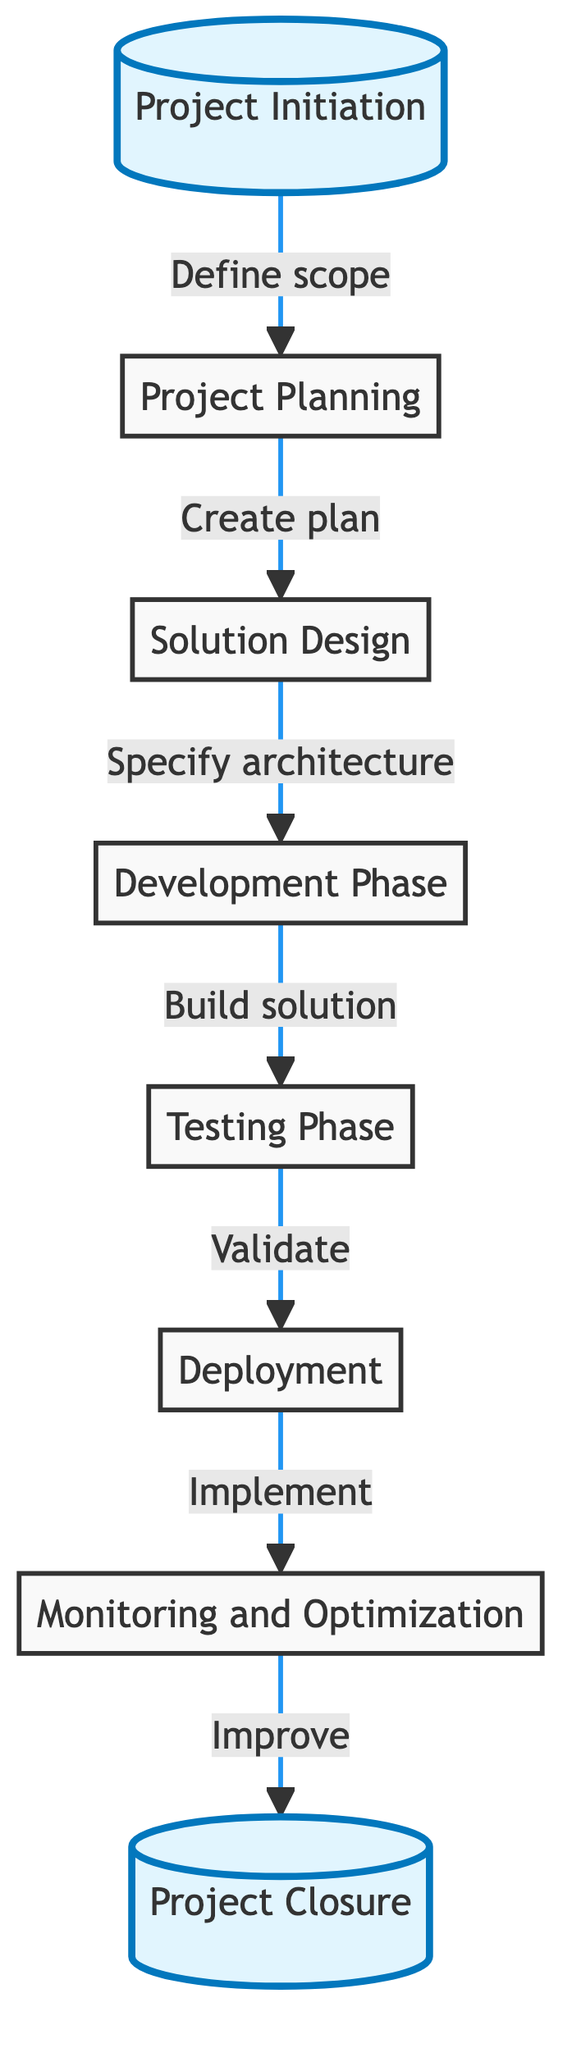What is the first phase of the automation project lifecycle? The diagram indicates that the first phase is "Project Initiation," which is positioned at the starting point of the flowchart.
Answer: Project Initiation How many total phases are there in the automation project lifecycle? By counting the nodes listed in the diagram, we find that there are eight distinct phases: Initiation, Planning, Design, Development, Testing, Deployment, Monitoring, and Closure.
Answer: Eight What phase comes directly after the Testing Phase? Following the flow of the diagram, the phase that directly follows "Testing Phase" is "Deployment." This indicates the sequence of operations in the project lifecycle.
Answer: Deployment Which phase involves creating a detailed project plan? According to the flowchart, the phase responsible for this task is "Project Planning," as it explicitly mentions developing a detailed project plan.
Answer: Project Planning What action follows the Deployment phase? The diagram shows that after "Deployment," the next action is "Monitoring and Optimization." This indicates the continuous process that occurs post-deployment.
Answer: Monitoring and Optimization What is the final phase in the automation project lifecycle? In the flowchart, the last phase is marked as "Project Closure," signifying the conclusion of the project lifecycle.
Answer: Project Closure Which two phases are highlighted in the diagram? The highlighted phases in the diagram are "Project Initiation" and "Project Closure," indicating their importance in the lifecycle process.
Answer: Project Initiation and Project Closure What is the connection between the Design phase and the Development phase? The flowchart indicates that the connection is established through the action "Specify architecture," which describes the relationship between these two phases.
Answer: Specify architecture 